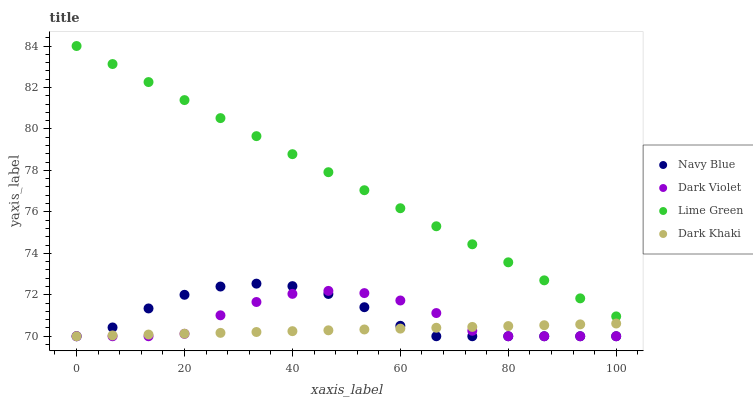Does Dark Khaki have the minimum area under the curve?
Answer yes or no. Yes. Does Lime Green have the maximum area under the curve?
Answer yes or no. Yes. Does Navy Blue have the minimum area under the curve?
Answer yes or no. No. Does Navy Blue have the maximum area under the curve?
Answer yes or no. No. Is Lime Green the smoothest?
Answer yes or no. Yes. Is Dark Violet the roughest?
Answer yes or no. Yes. Is Navy Blue the smoothest?
Answer yes or no. No. Is Navy Blue the roughest?
Answer yes or no. No. Does Dark Khaki have the lowest value?
Answer yes or no. Yes. Does Lime Green have the lowest value?
Answer yes or no. No. Does Lime Green have the highest value?
Answer yes or no. Yes. Does Navy Blue have the highest value?
Answer yes or no. No. Is Dark Violet less than Lime Green?
Answer yes or no. Yes. Is Lime Green greater than Navy Blue?
Answer yes or no. Yes. Does Dark Violet intersect Navy Blue?
Answer yes or no. Yes. Is Dark Violet less than Navy Blue?
Answer yes or no. No. Is Dark Violet greater than Navy Blue?
Answer yes or no. No. Does Dark Violet intersect Lime Green?
Answer yes or no. No. 